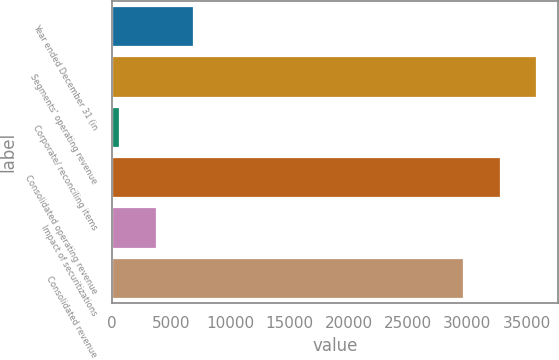<chart> <loc_0><loc_0><loc_500><loc_500><bar_chart><fcel>Year ended December 31 (in<fcel>Segments' operating revenue<fcel>Corporate/ reconciling items<fcel>Consolidated operating revenue<fcel>Impact of securitizations<fcel>Consolidated revenue<nl><fcel>6836.6<fcel>35824.6<fcel>626<fcel>32719.3<fcel>3731.3<fcel>29614<nl></chart> 